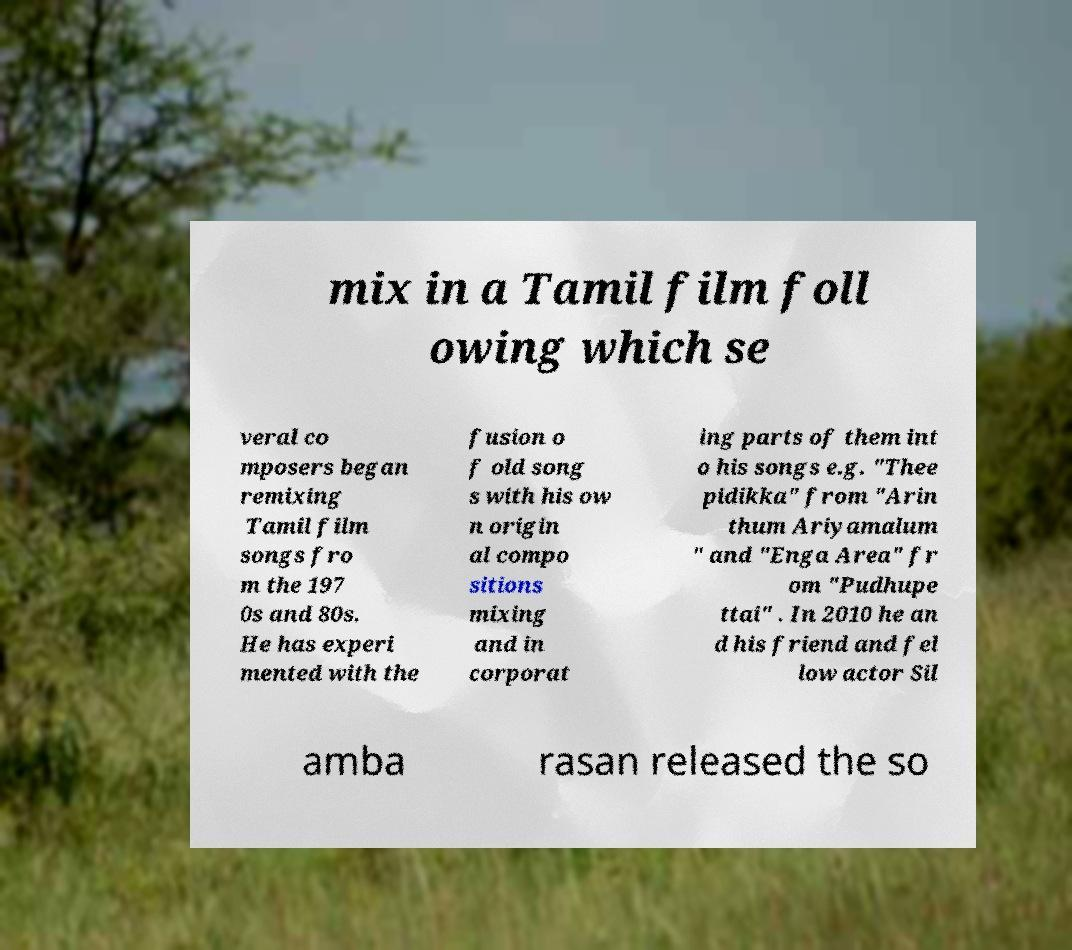Please read and relay the text visible in this image. What does it say? mix in a Tamil film foll owing which se veral co mposers began remixing Tamil film songs fro m the 197 0s and 80s. He has experi mented with the fusion o f old song s with his ow n origin al compo sitions mixing and in corporat ing parts of them int o his songs e.g. "Thee pidikka" from "Arin thum Ariyamalum " and "Enga Area" fr om "Pudhupe ttai" . In 2010 he an d his friend and fel low actor Sil amba rasan released the so 